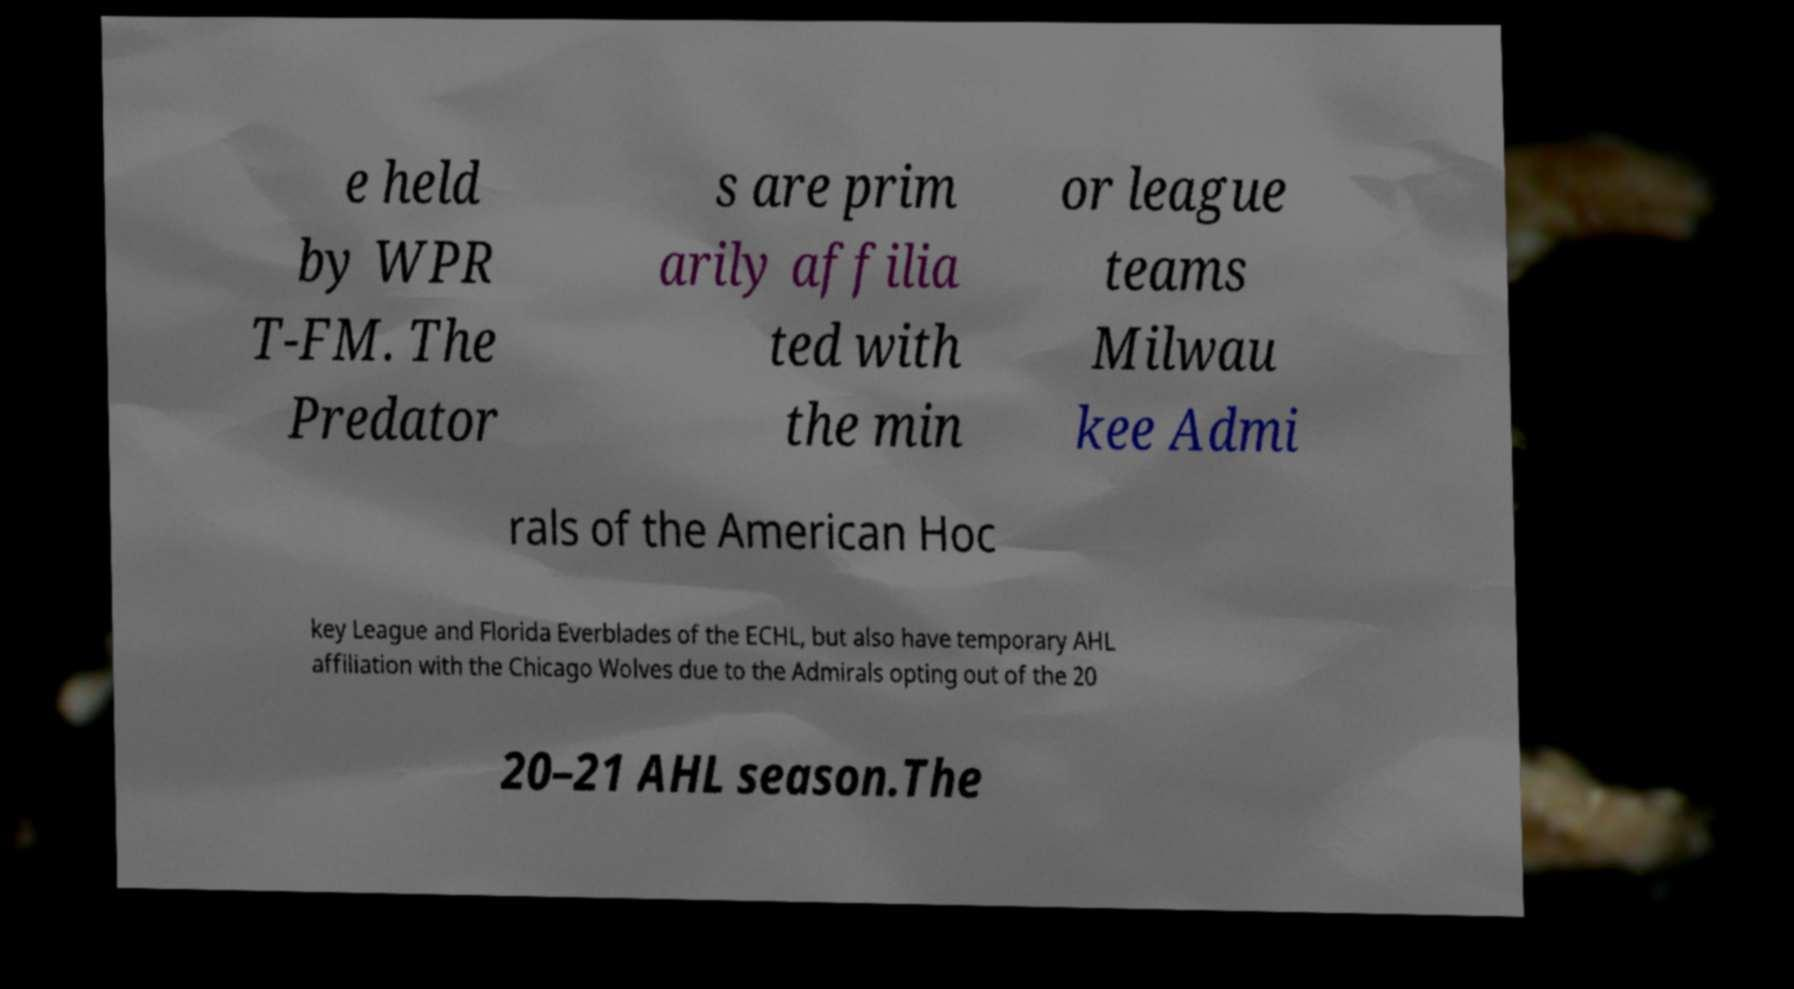Please identify and transcribe the text found in this image. e held by WPR T-FM. The Predator s are prim arily affilia ted with the min or league teams Milwau kee Admi rals of the American Hoc key League and Florida Everblades of the ECHL, but also have temporary AHL affiliation with the Chicago Wolves due to the Admirals opting out of the 20 20–21 AHL season.The 